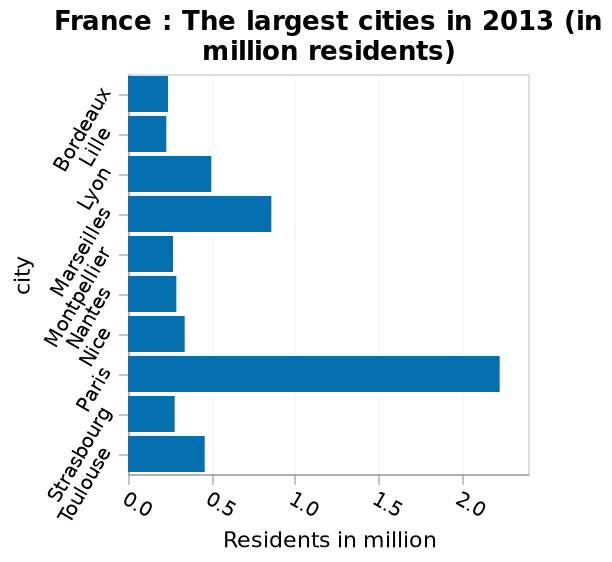<image>
What type of graph is being used to represent the data? The bar graph is being used to represent the data. What information does the bar graph provide? The bar graph provides information about the number of residents in million in the largest cities of France in 2013. 